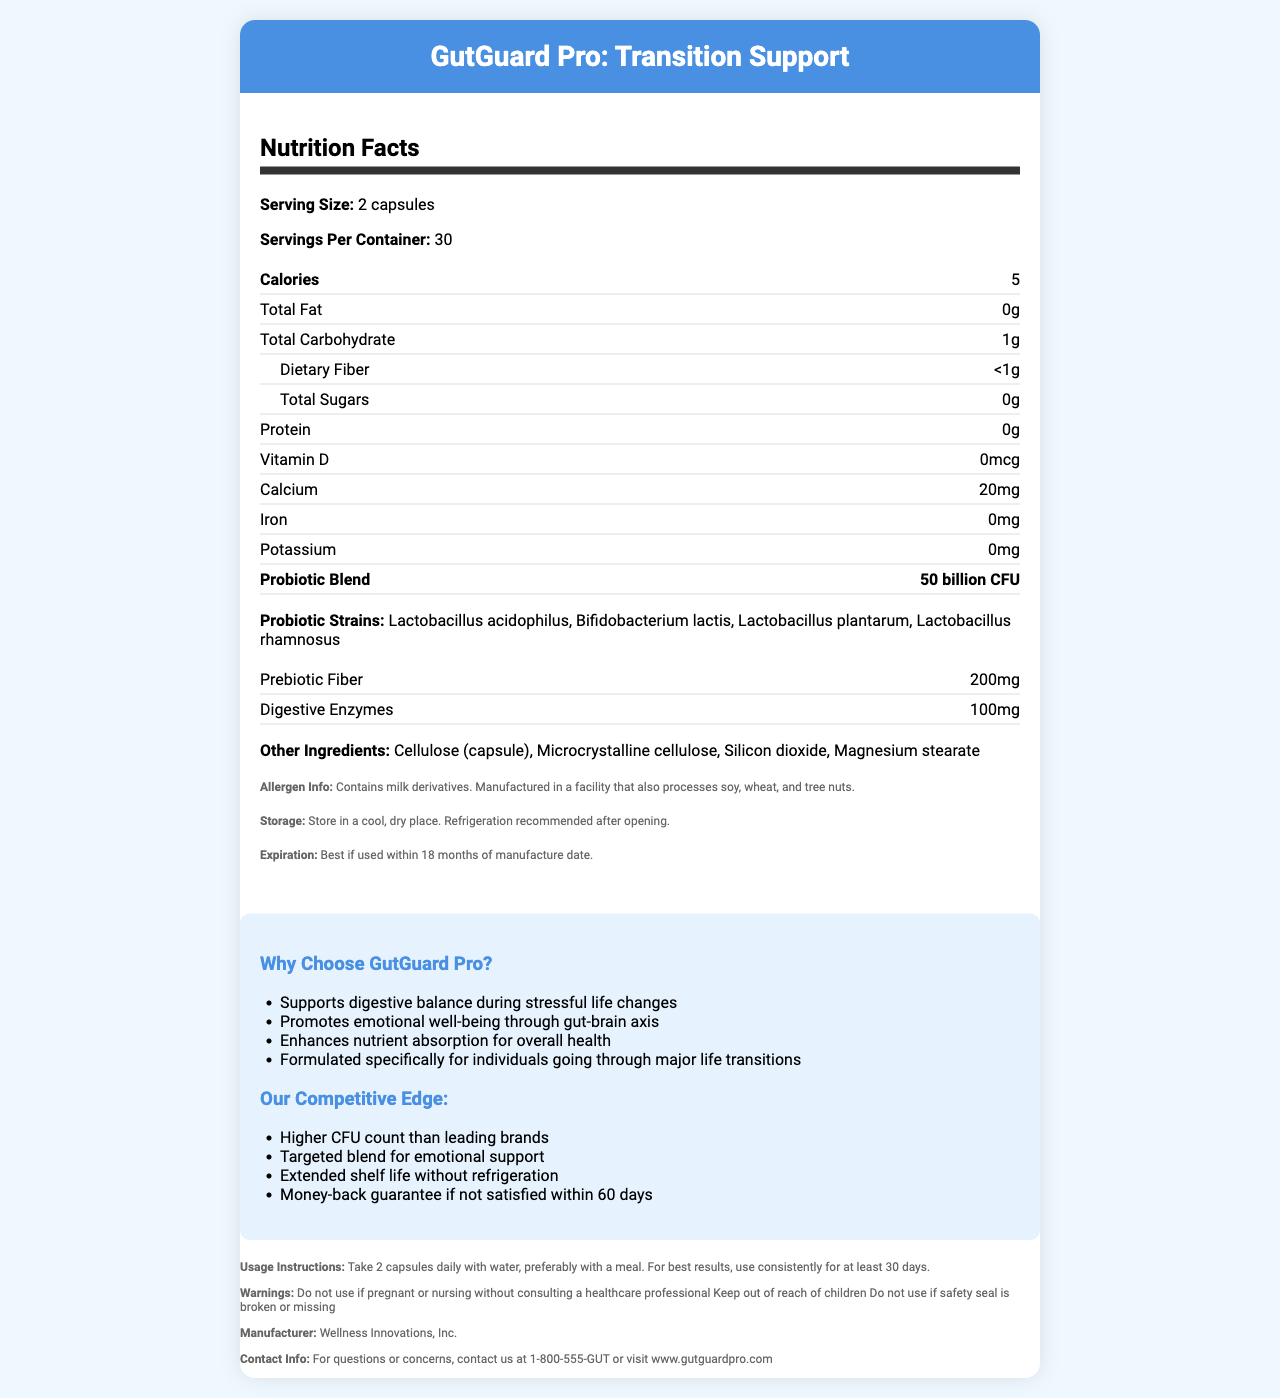what is the product name? The product name is mentioned at the top of the document in the header section.
Answer: GutGuard Pro: Transition Support how many servings are in one container? The label indicates "Servings Per Container: 30".
Answer: 30 how many calories are in one serving? The label lists that each serving of 2 capsules contains 5 calories.
Answer: 5 what is the CFU count of the probiotic blend? The label specifies "Probiotic Blend: 50 billion CFU".
Answer: 50 billion CFU what allergens are present in the product? The allergen information section states, "Contains milk derivatives."
Answer: milk derivatives which probiotic strains are included in the blend? A. Lactobacillus acidophilus, Bifidobacterium lactis, Lactobacillus plantarum B. Lactobacillus acidophilus, Bifidobacterium bifidum, Lactobacillus plantarum C. Lactobacillus acidophilus, Bifidobacterium lactis, Lactobacillus rhamnosus The document lists the probiotic strains as "Lactobacillus acidophilus, Bifidobacterium lactis, Lactobacillus plantarum, Lactobacillus rhamnosus."
Answer: A what is the recommended storage condition for this supplement? A. Store in a warm, dry place B. Store in a cool, dry place C. Store in a humid place The storage section of the document advises, "Store in a cool, dry place."
Answer: B is this product safe for pregnant or nursing women without consulting a healthcare professional? The warnings section indicates that pregnant or nursing women should consult a healthcare professional before using the product.
Answer: No summarize the main idea of the document The document aims to inform potential users about the product's benefits, ingredients, and usage while ensuring they are aware of any allergens and storage requirements.
Answer: The document provides detailed information about GutGuard Pro: Transition Support, a probiotic supplement designed to support gut health and well-being during life transitions. It includes nutritional facts, serving size, ingredients, allergen info, storage instructions, expiration, marketing claims, competitive advantages, usage instructions, warnings, and contact details. does the product contain any Vitamin D? The nutrition facts section lists "Vitamin D: 0mcg," indicating the product does not contain any Vitamin D.
Answer: No what is the calcium content per serving? The nutrition facts section lists "Calcium: 20mg" per serving.
Answer: 20mg which fiber type is included in the supplement? The document states "Prebiotic Fiber: 200mg" in the nutrition section.
Answer: Prebiotic Fiber how long is the money-back guarantee period for the product? One of the competitive edges mentioned is a "Money-back guarantee if not satisfied within 60 days."
Answer: 60 days what is the contact phone number for customer inquiries? The contact information section provides the phone number for customer inquiries.
Answer: 1-800-555-GUT where is the manufacturer located? The document does not provide information about the location of the manufacturer. It only mentions the manufacturer’s name, "Wellness Innovations, Inc."
Answer: Cannot be determined 